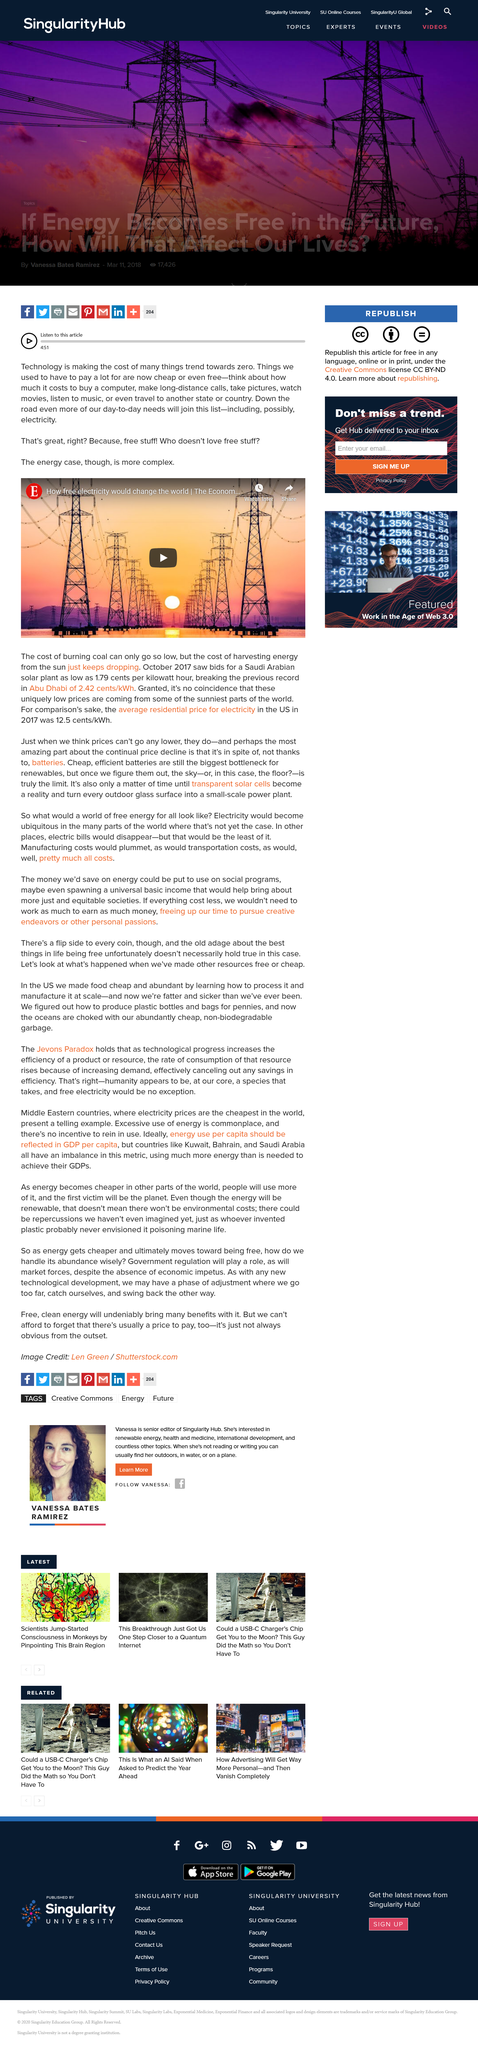Highlight a few significant elements in this photo. In 2017, the average residential price for electricity in the US was 12.5 cents per kilowatt-hour. The bid for a Saudi Arabian solar plant is 1.79 cents per kilowatt hour. The cost of harvesting energy from the sun has consistently been decreasing over time, making it increasingly affordable and accessible. 